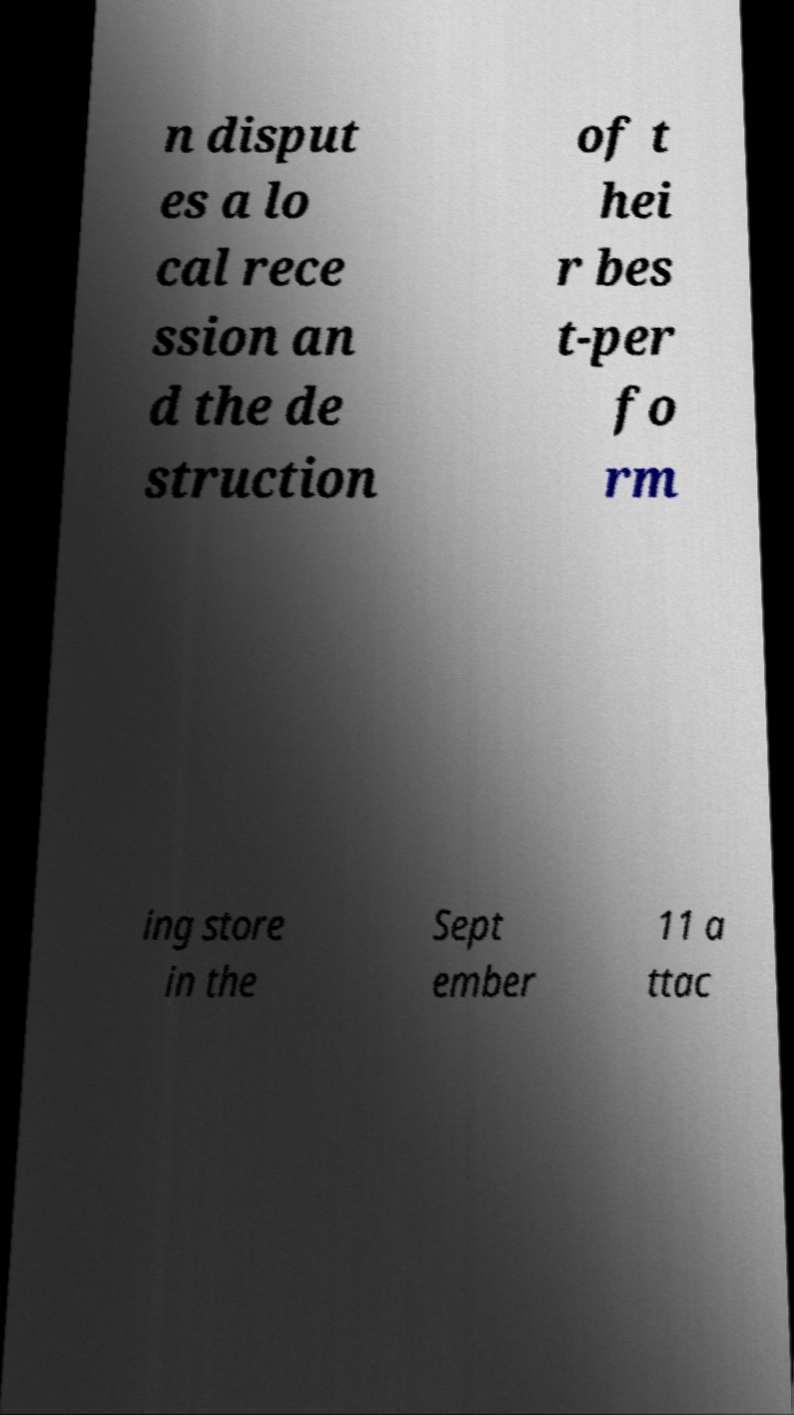For documentation purposes, I need the text within this image transcribed. Could you provide that? n disput es a lo cal rece ssion an d the de struction of t hei r bes t-per fo rm ing store in the Sept ember 11 a ttac 